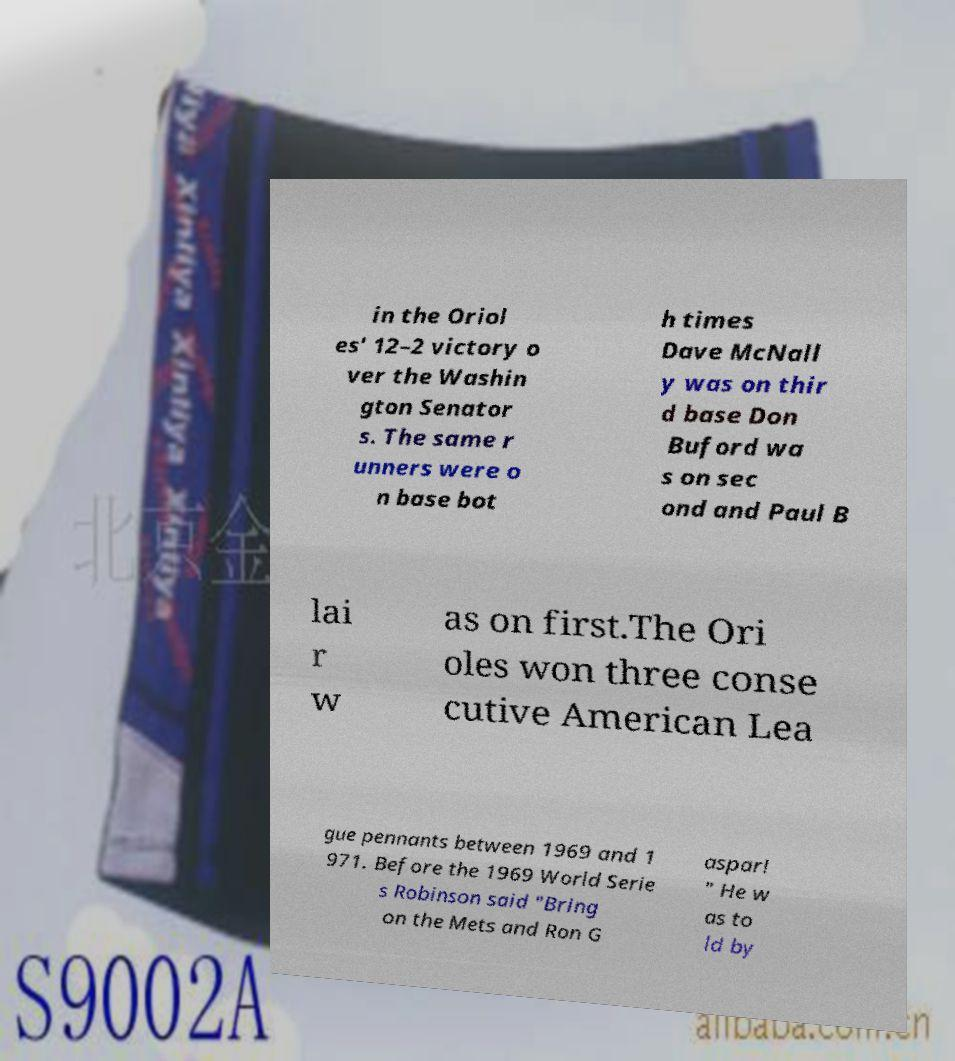There's text embedded in this image that I need extracted. Can you transcribe it verbatim? in the Oriol es' 12–2 victory o ver the Washin gton Senator s. The same r unners were o n base bot h times Dave McNall y was on thir d base Don Buford wa s on sec ond and Paul B lai r w as on first.The Ori oles won three conse cutive American Lea gue pennants between 1969 and 1 971. Before the 1969 World Serie s Robinson said "Bring on the Mets and Ron G aspar! " He w as to ld by 